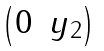<formula> <loc_0><loc_0><loc_500><loc_500>\begin{pmatrix} 0 & y _ { 2 } \end{pmatrix}</formula> 